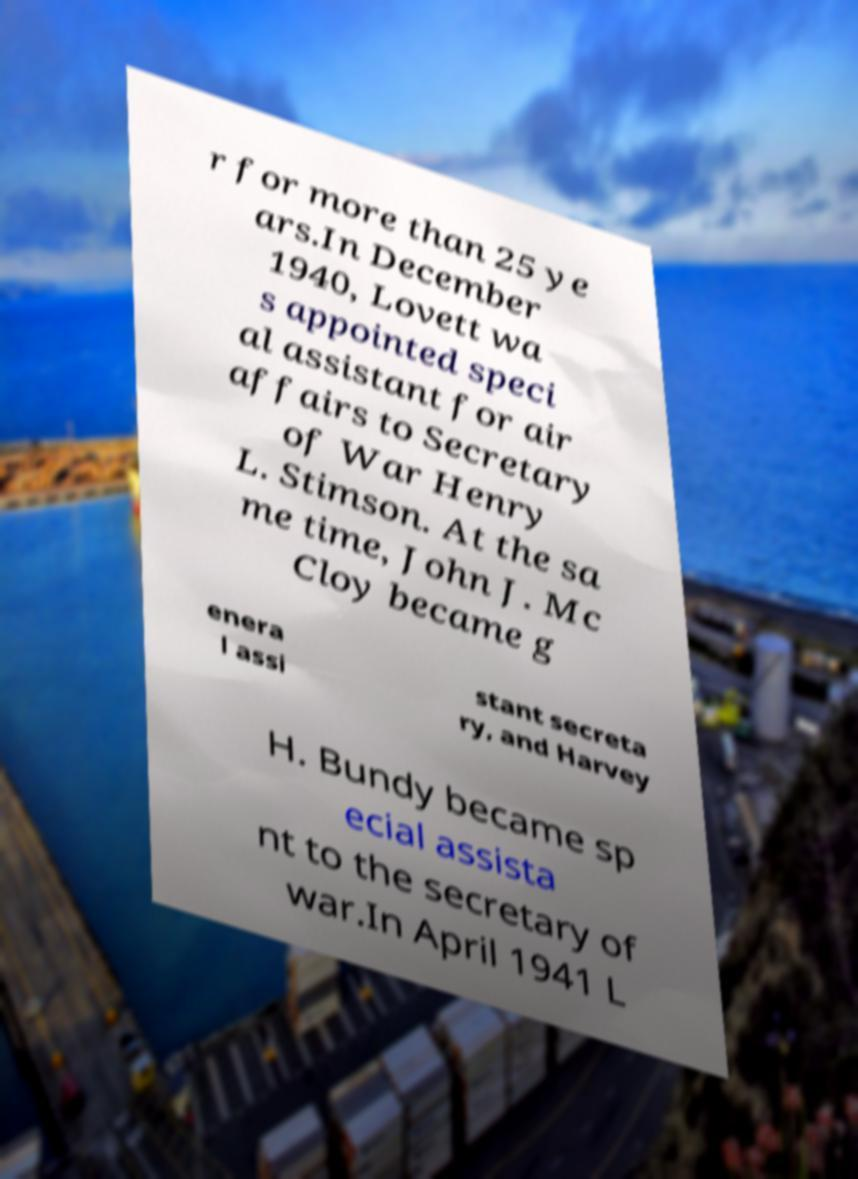Could you extract and type out the text from this image? r for more than 25 ye ars.In December 1940, Lovett wa s appointed speci al assistant for air affairs to Secretary of War Henry L. Stimson. At the sa me time, John J. Mc Cloy became g enera l assi stant secreta ry, and Harvey H. Bundy became sp ecial assista nt to the secretary of war.In April 1941 L 